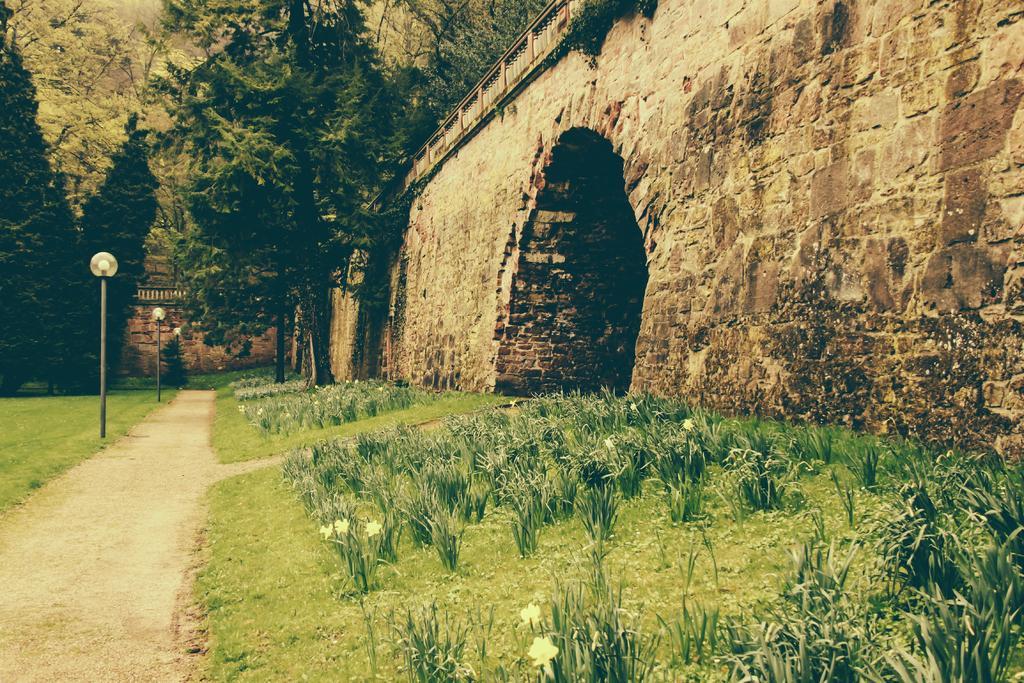Please provide a concise description of this image. On the left side, there is a road, near lights attached to the poles. Which are on the grass on the ground. On the right side, there is wall of a bridge, near plants, some of them are having white color flowers and grass on the ground. In the background, there are trees, there is wall and there's grass on the ground. 